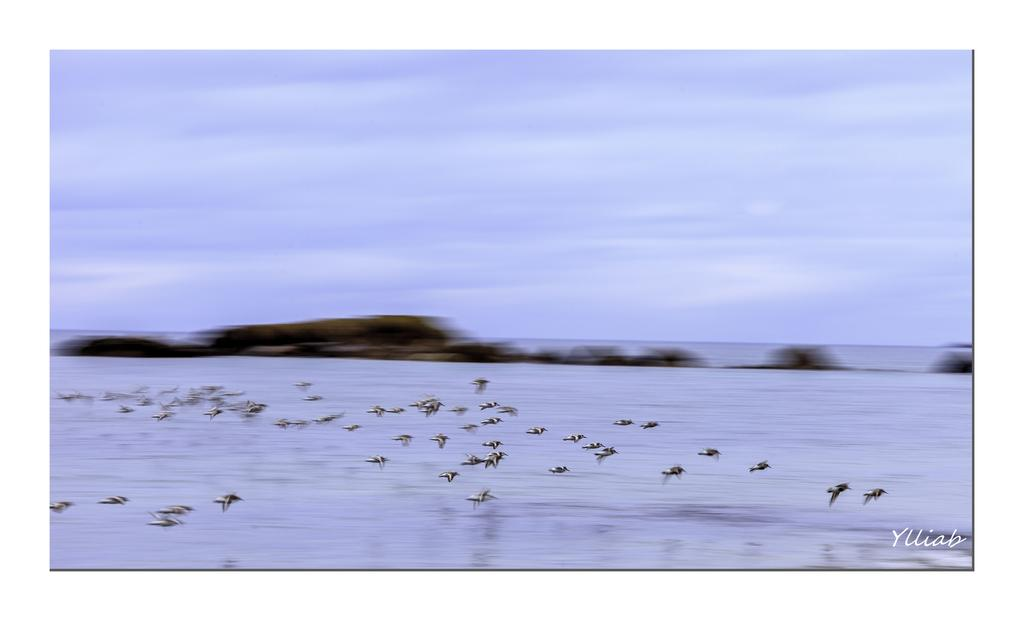What is happening in the image? There are many birds flying in the image. What can be seen below the birds? There is water visible in the image. What is visible in the background of the image? The sky is visible in the background of the image. What time of day is it in the image, and what color is the cat's fur? There is no indication of the time of day in the image, and there is no cat present. 